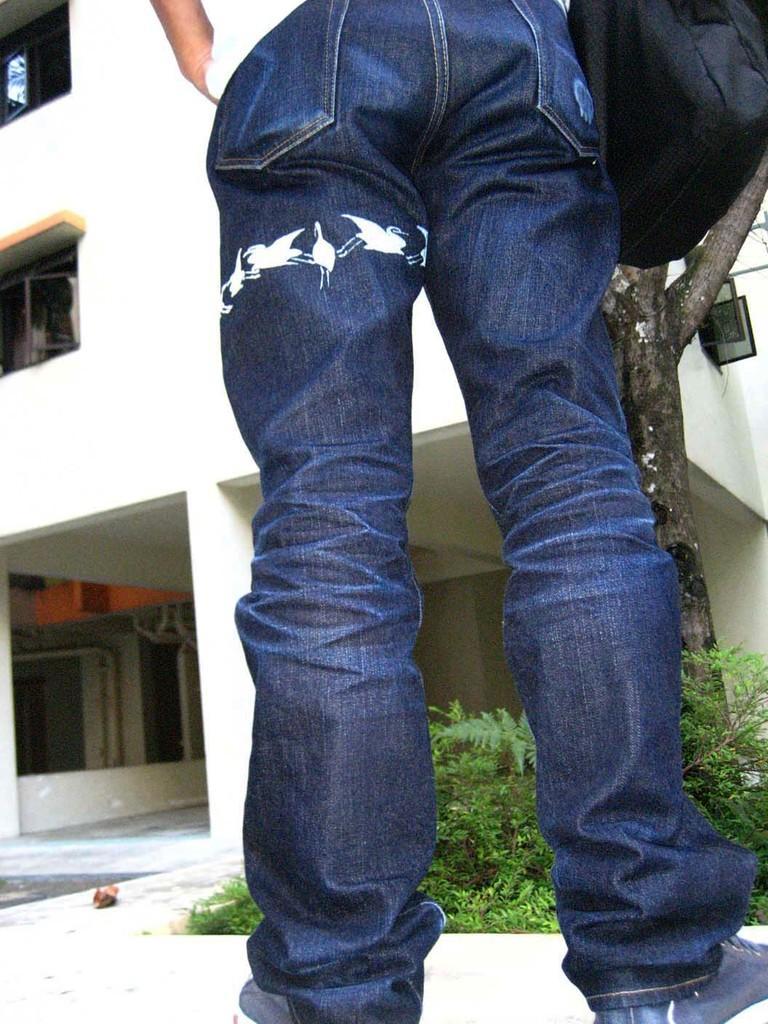Could you give a brief overview of what you see in this image? In this image, we can see a person. We can see the ground. We can see some plants and the trunk of a tree. We can also see the building and a black colored object on the right. 